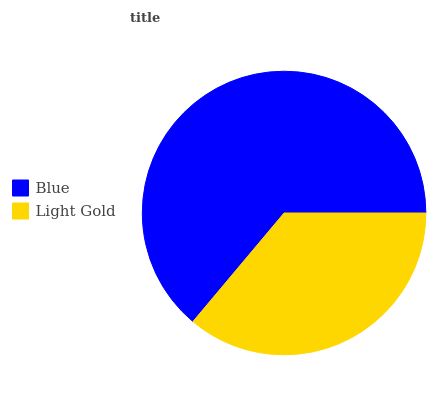Is Light Gold the minimum?
Answer yes or no. Yes. Is Blue the maximum?
Answer yes or no. Yes. Is Light Gold the maximum?
Answer yes or no. No. Is Blue greater than Light Gold?
Answer yes or no. Yes. Is Light Gold less than Blue?
Answer yes or no. Yes. Is Light Gold greater than Blue?
Answer yes or no. No. Is Blue less than Light Gold?
Answer yes or no. No. Is Blue the high median?
Answer yes or no. Yes. Is Light Gold the low median?
Answer yes or no. Yes. Is Light Gold the high median?
Answer yes or no. No. Is Blue the low median?
Answer yes or no. No. 